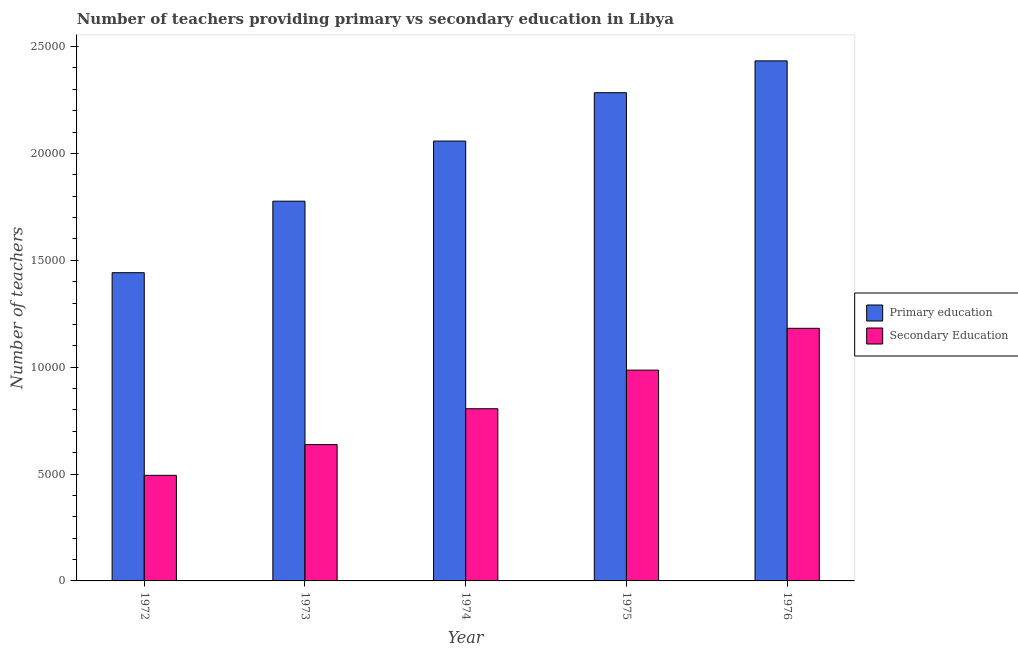How many different coloured bars are there?
Keep it short and to the point. 2. Are the number of bars on each tick of the X-axis equal?
Ensure brevity in your answer.  Yes. How many bars are there on the 5th tick from the left?
Keep it short and to the point. 2. How many bars are there on the 1st tick from the right?
Offer a very short reply. 2. What is the number of secondary teachers in 1974?
Offer a terse response. 8056. Across all years, what is the maximum number of primary teachers?
Give a very brief answer. 2.43e+04. Across all years, what is the minimum number of primary teachers?
Provide a short and direct response. 1.44e+04. In which year was the number of primary teachers maximum?
Provide a short and direct response. 1976. In which year was the number of primary teachers minimum?
Provide a short and direct response. 1972. What is the total number of primary teachers in the graph?
Keep it short and to the point. 9.99e+04. What is the difference between the number of secondary teachers in 1975 and that in 1976?
Keep it short and to the point. -1957. What is the difference between the number of secondary teachers in 1973 and the number of primary teachers in 1976?
Provide a succinct answer. -5440. What is the average number of secondary teachers per year?
Your answer should be compact. 8211.2. In how many years, is the number of secondary teachers greater than 1000?
Ensure brevity in your answer.  5. What is the ratio of the number of primary teachers in 1973 to that in 1975?
Your answer should be compact. 0.78. Is the number of secondary teachers in 1974 less than that in 1976?
Your answer should be compact. Yes. Is the difference between the number of primary teachers in 1973 and 1975 greater than the difference between the number of secondary teachers in 1973 and 1975?
Keep it short and to the point. No. What is the difference between the highest and the second highest number of secondary teachers?
Offer a very short reply. 1957. What is the difference between the highest and the lowest number of primary teachers?
Keep it short and to the point. 9910. In how many years, is the number of secondary teachers greater than the average number of secondary teachers taken over all years?
Keep it short and to the point. 2. Is the sum of the number of primary teachers in 1972 and 1974 greater than the maximum number of secondary teachers across all years?
Provide a short and direct response. Yes. What does the 2nd bar from the left in 1973 represents?
Offer a terse response. Secondary Education. What does the 1st bar from the right in 1976 represents?
Make the answer very short. Secondary Education. Are the values on the major ticks of Y-axis written in scientific E-notation?
Ensure brevity in your answer.  No. Does the graph contain grids?
Your answer should be very brief. No. How are the legend labels stacked?
Make the answer very short. Vertical. What is the title of the graph?
Your answer should be compact. Number of teachers providing primary vs secondary education in Libya. Does "Age 15+" appear as one of the legend labels in the graph?
Ensure brevity in your answer.  No. What is the label or title of the X-axis?
Provide a short and direct response. Year. What is the label or title of the Y-axis?
Keep it short and to the point. Number of teachers. What is the Number of teachers of Primary education in 1972?
Ensure brevity in your answer.  1.44e+04. What is the Number of teachers of Secondary Education in 1972?
Your answer should be compact. 4940. What is the Number of teachers of Primary education in 1973?
Keep it short and to the point. 1.78e+04. What is the Number of teachers of Secondary Education in 1973?
Your response must be concise. 6379. What is the Number of teachers in Primary education in 1974?
Offer a very short reply. 2.06e+04. What is the Number of teachers of Secondary Education in 1974?
Keep it short and to the point. 8056. What is the Number of teachers of Primary education in 1975?
Ensure brevity in your answer.  2.28e+04. What is the Number of teachers in Secondary Education in 1975?
Provide a succinct answer. 9862. What is the Number of teachers of Primary education in 1976?
Your answer should be very brief. 2.43e+04. What is the Number of teachers in Secondary Education in 1976?
Offer a very short reply. 1.18e+04. Across all years, what is the maximum Number of teachers in Primary education?
Ensure brevity in your answer.  2.43e+04. Across all years, what is the maximum Number of teachers in Secondary Education?
Your answer should be very brief. 1.18e+04. Across all years, what is the minimum Number of teachers in Primary education?
Your answer should be very brief. 1.44e+04. Across all years, what is the minimum Number of teachers in Secondary Education?
Your answer should be compact. 4940. What is the total Number of teachers of Primary education in the graph?
Provide a short and direct response. 9.99e+04. What is the total Number of teachers in Secondary Education in the graph?
Your response must be concise. 4.11e+04. What is the difference between the Number of teachers of Primary education in 1972 and that in 1973?
Provide a succinct answer. -3346. What is the difference between the Number of teachers of Secondary Education in 1972 and that in 1973?
Your answer should be compact. -1439. What is the difference between the Number of teachers of Primary education in 1972 and that in 1974?
Your answer should be very brief. -6159. What is the difference between the Number of teachers in Secondary Education in 1972 and that in 1974?
Provide a succinct answer. -3116. What is the difference between the Number of teachers of Primary education in 1972 and that in 1975?
Offer a very short reply. -8421. What is the difference between the Number of teachers in Secondary Education in 1972 and that in 1975?
Make the answer very short. -4922. What is the difference between the Number of teachers in Primary education in 1972 and that in 1976?
Keep it short and to the point. -9910. What is the difference between the Number of teachers of Secondary Education in 1972 and that in 1976?
Offer a terse response. -6879. What is the difference between the Number of teachers of Primary education in 1973 and that in 1974?
Your response must be concise. -2813. What is the difference between the Number of teachers in Secondary Education in 1973 and that in 1974?
Provide a short and direct response. -1677. What is the difference between the Number of teachers in Primary education in 1973 and that in 1975?
Your response must be concise. -5075. What is the difference between the Number of teachers in Secondary Education in 1973 and that in 1975?
Your answer should be compact. -3483. What is the difference between the Number of teachers of Primary education in 1973 and that in 1976?
Ensure brevity in your answer.  -6564. What is the difference between the Number of teachers of Secondary Education in 1973 and that in 1976?
Your answer should be compact. -5440. What is the difference between the Number of teachers in Primary education in 1974 and that in 1975?
Your response must be concise. -2262. What is the difference between the Number of teachers of Secondary Education in 1974 and that in 1975?
Keep it short and to the point. -1806. What is the difference between the Number of teachers in Primary education in 1974 and that in 1976?
Offer a terse response. -3751. What is the difference between the Number of teachers in Secondary Education in 1974 and that in 1976?
Offer a terse response. -3763. What is the difference between the Number of teachers in Primary education in 1975 and that in 1976?
Provide a succinct answer. -1489. What is the difference between the Number of teachers in Secondary Education in 1975 and that in 1976?
Your response must be concise. -1957. What is the difference between the Number of teachers in Primary education in 1972 and the Number of teachers in Secondary Education in 1973?
Make the answer very short. 8042. What is the difference between the Number of teachers of Primary education in 1972 and the Number of teachers of Secondary Education in 1974?
Ensure brevity in your answer.  6365. What is the difference between the Number of teachers in Primary education in 1972 and the Number of teachers in Secondary Education in 1975?
Your answer should be very brief. 4559. What is the difference between the Number of teachers of Primary education in 1972 and the Number of teachers of Secondary Education in 1976?
Provide a short and direct response. 2602. What is the difference between the Number of teachers of Primary education in 1973 and the Number of teachers of Secondary Education in 1974?
Your answer should be compact. 9711. What is the difference between the Number of teachers of Primary education in 1973 and the Number of teachers of Secondary Education in 1975?
Your answer should be compact. 7905. What is the difference between the Number of teachers in Primary education in 1973 and the Number of teachers in Secondary Education in 1976?
Keep it short and to the point. 5948. What is the difference between the Number of teachers in Primary education in 1974 and the Number of teachers in Secondary Education in 1975?
Offer a very short reply. 1.07e+04. What is the difference between the Number of teachers in Primary education in 1974 and the Number of teachers in Secondary Education in 1976?
Provide a succinct answer. 8761. What is the difference between the Number of teachers in Primary education in 1975 and the Number of teachers in Secondary Education in 1976?
Offer a very short reply. 1.10e+04. What is the average Number of teachers in Primary education per year?
Offer a very short reply. 2.00e+04. What is the average Number of teachers of Secondary Education per year?
Your answer should be very brief. 8211.2. In the year 1972, what is the difference between the Number of teachers in Primary education and Number of teachers in Secondary Education?
Give a very brief answer. 9481. In the year 1973, what is the difference between the Number of teachers in Primary education and Number of teachers in Secondary Education?
Your answer should be very brief. 1.14e+04. In the year 1974, what is the difference between the Number of teachers of Primary education and Number of teachers of Secondary Education?
Your answer should be compact. 1.25e+04. In the year 1975, what is the difference between the Number of teachers of Primary education and Number of teachers of Secondary Education?
Provide a short and direct response. 1.30e+04. In the year 1976, what is the difference between the Number of teachers in Primary education and Number of teachers in Secondary Education?
Give a very brief answer. 1.25e+04. What is the ratio of the Number of teachers of Primary education in 1972 to that in 1973?
Your response must be concise. 0.81. What is the ratio of the Number of teachers of Secondary Education in 1972 to that in 1973?
Provide a succinct answer. 0.77. What is the ratio of the Number of teachers in Primary education in 1972 to that in 1974?
Provide a short and direct response. 0.7. What is the ratio of the Number of teachers of Secondary Education in 1972 to that in 1974?
Your response must be concise. 0.61. What is the ratio of the Number of teachers of Primary education in 1972 to that in 1975?
Your answer should be very brief. 0.63. What is the ratio of the Number of teachers in Secondary Education in 1972 to that in 1975?
Your answer should be compact. 0.5. What is the ratio of the Number of teachers of Primary education in 1972 to that in 1976?
Offer a terse response. 0.59. What is the ratio of the Number of teachers in Secondary Education in 1972 to that in 1976?
Offer a very short reply. 0.42. What is the ratio of the Number of teachers of Primary education in 1973 to that in 1974?
Provide a short and direct response. 0.86. What is the ratio of the Number of teachers in Secondary Education in 1973 to that in 1974?
Your response must be concise. 0.79. What is the ratio of the Number of teachers in Secondary Education in 1973 to that in 1975?
Offer a very short reply. 0.65. What is the ratio of the Number of teachers of Primary education in 1973 to that in 1976?
Provide a short and direct response. 0.73. What is the ratio of the Number of teachers of Secondary Education in 1973 to that in 1976?
Offer a very short reply. 0.54. What is the ratio of the Number of teachers of Primary education in 1974 to that in 1975?
Provide a short and direct response. 0.9. What is the ratio of the Number of teachers of Secondary Education in 1974 to that in 1975?
Offer a very short reply. 0.82. What is the ratio of the Number of teachers of Primary education in 1974 to that in 1976?
Your answer should be compact. 0.85. What is the ratio of the Number of teachers of Secondary Education in 1974 to that in 1976?
Ensure brevity in your answer.  0.68. What is the ratio of the Number of teachers of Primary education in 1975 to that in 1976?
Your answer should be very brief. 0.94. What is the ratio of the Number of teachers in Secondary Education in 1975 to that in 1976?
Offer a very short reply. 0.83. What is the difference between the highest and the second highest Number of teachers in Primary education?
Provide a succinct answer. 1489. What is the difference between the highest and the second highest Number of teachers of Secondary Education?
Make the answer very short. 1957. What is the difference between the highest and the lowest Number of teachers in Primary education?
Keep it short and to the point. 9910. What is the difference between the highest and the lowest Number of teachers in Secondary Education?
Provide a succinct answer. 6879. 